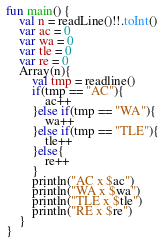Convert code to text. <code><loc_0><loc_0><loc_500><loc_500><_Kotlin_>fun main() {
    val n = readLine()!!.toInt()
    var ac = 0
    var wa = 0
    var tle = 0
    var re = 0
    Array(n){
        val tmp = readline()
        if(tmp == "AC"){
            ac++
        }else if(tmp == "WA"){
            wa++
        }else if(tmp == "TLE"){
            tle++
        }else{
            re++
        }
        println("AC x $ac")
        println("WA x $wa")
        println("TLE x $tle")
        println("RE x $re")
    }
}</code> 